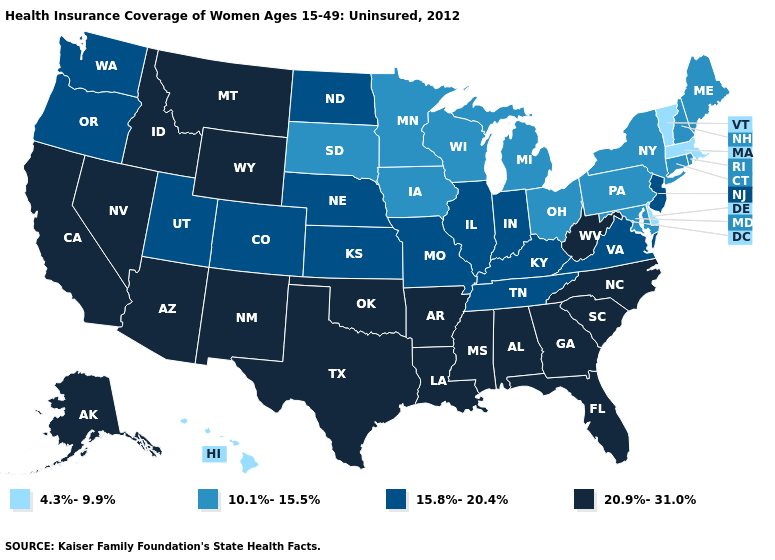What is the highest value in states that border Indiana?
Keep it brief. 15.8%-20.4%. What is the highest value in the West ?
Write a very short answer. 20.9%-31.0%. Does the first symbol in the legend represent the smallest category?
Answer briefly. Yes. Name the states that have a value in the range 4.3%-9.9%?
Short answer required. Delaware, Hawaii, Massachusetts, Vermont. Which states have the lowest value in the USA?
Keep it brief. Delaware, Hawaii, Massachusetts, Vermont. Does Alabama have the highest value in the South?
Quick response, please. Yes. What is the value of Iowa?
Short answer required. 10.1%-15.5%. What is the value of Arkansas?
Be succinct. 20.9%-31.0%. How many symbols are there in the legend?
Keep it brief. 4. What is the value of Pennsylvania?
Write a very short answer. 10.1%-15.5%. What is the value of Louisiana?
Answer briefly. 20.9%-31.0%. What is the value of California?
Write a very short answer. 20.9%-31.0%. Among the states that border South Carolina , which have the highest value?
Be succinct. Georgia, North Carolina. Does Oklahoma have the lowest value in the South?
Write a very short answer. No. Which states have the highest value in the USA?
Short answer required. Alabama, Alaska, Arizona, Arkansas, California, Florida, Georgia, Idaho, Louisiana, Mississippi, Montana, Nevada, New Mexico, North Carolina, Oklahoma, South Carolina, Texas, West Virginia, Wyoming. 